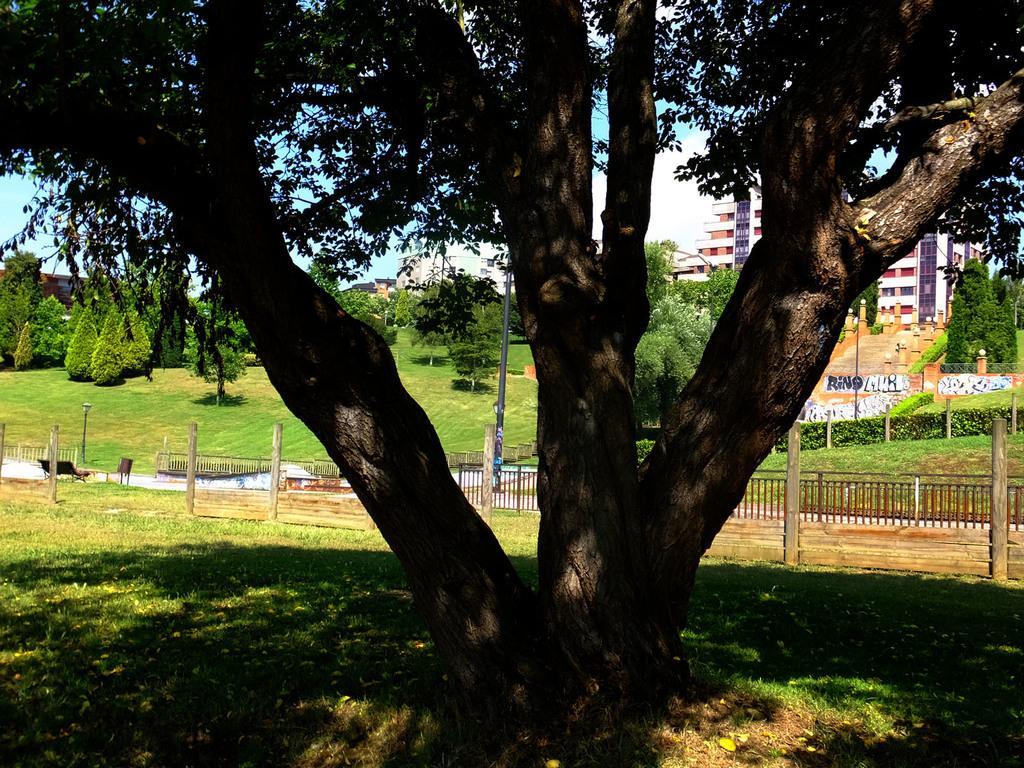Could you give a brief overview of what you see in this image? In the image we can see there are many trees. There is grass, fence, bench, wooden pole, building, stairs and a text. We can see a cloudy sky. 